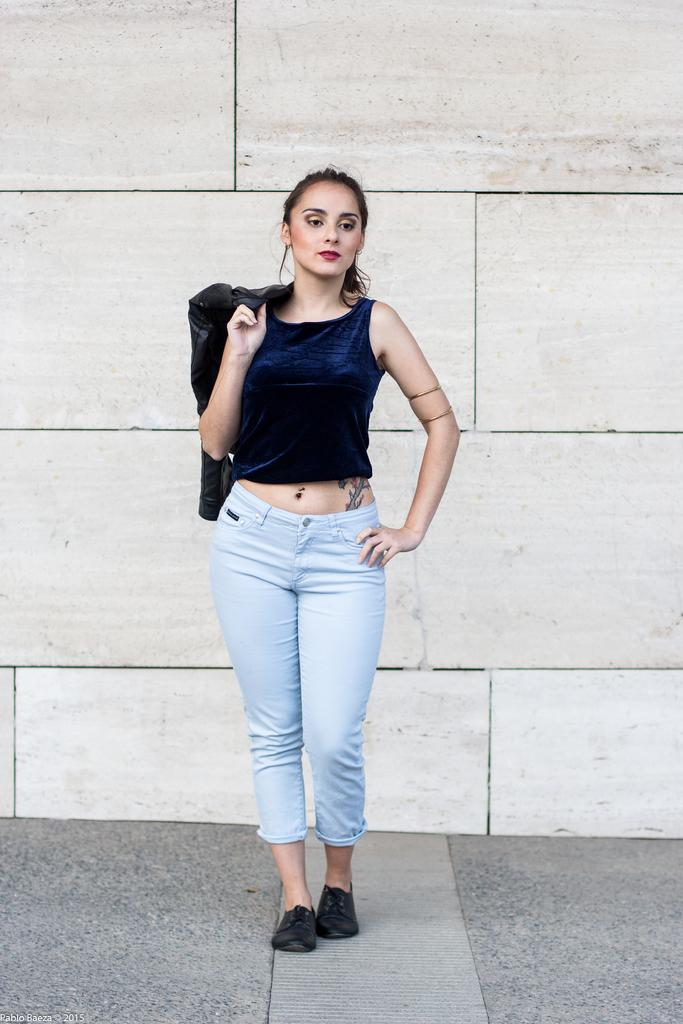Who is the main subject in the image? There is a woman in the image. Where is the woman located in the image? The woman is standing in the middle of the image. What is the woman doing in the image? The woman is watching something. What object is the woman holding in the image? The woman is holding a jacket. What can be seen behind the woman in the image? There is a wall visible behind the woman. What type of marble is the woman wearing on her head in the image? There is no marble or crown present in the image. The woman is not wearing any headgear. 